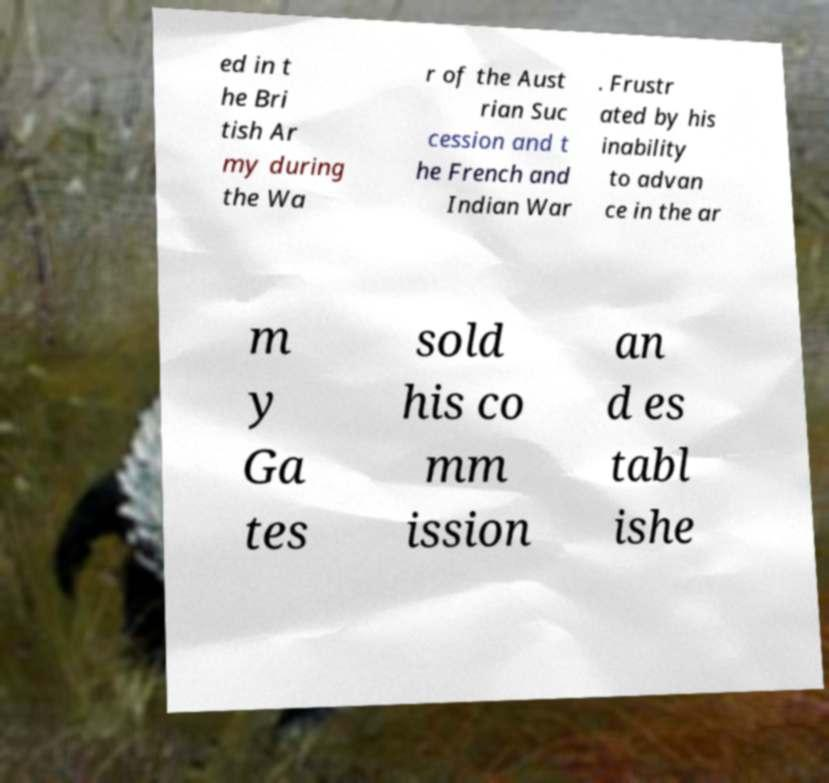Could you extract and type out the text from this image? ed in t he Bri tish Ar my during the Wa r of the Aust rian Suc cession and t he French and Indian War . Frustr ated by his inability to advan ce in the ar m y Ga tes sold his co mm ission an d es tabl ishe 